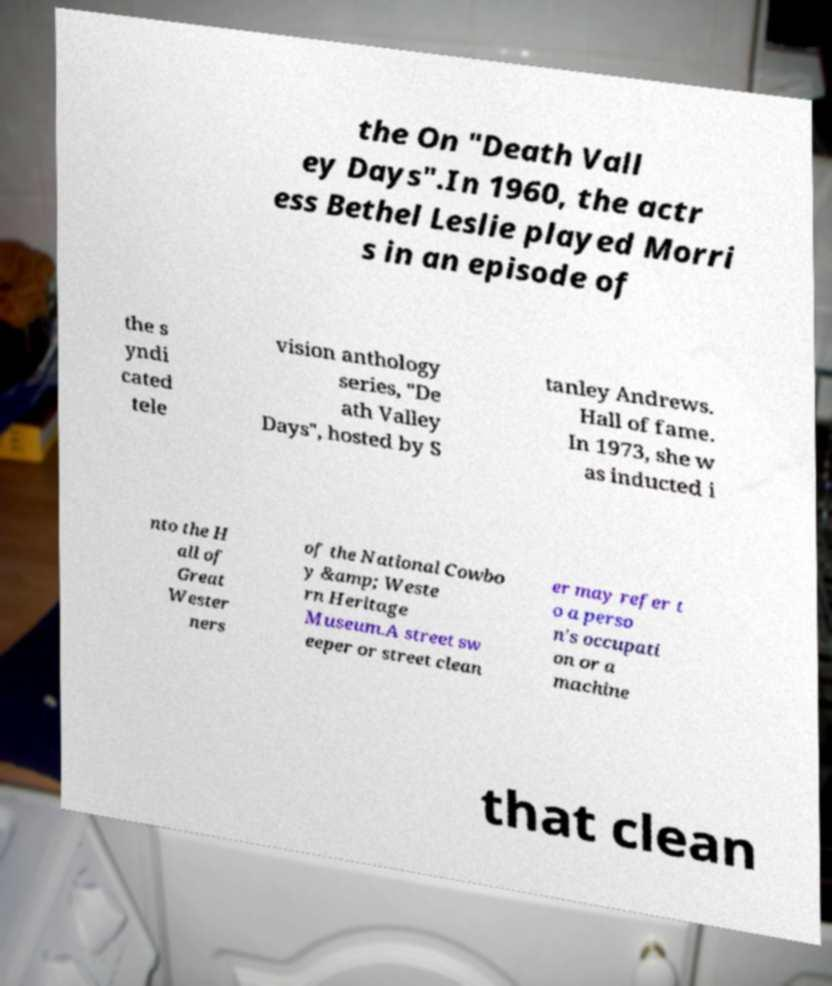There's text embedded in this image that I need extracted. Can you transcribe it verbatim? the On "Death Vall ey Days".In 1960, the actr ess Bethel Leslie played Morri s in an episode of the s yndi cated tele vision anthology series, "De ath Valley Days", hosted by S tanley Andrews. Hall of fame. In 1973, she w as inducted i nto the H all of Great Wester ners of the National Cowbo y &amp; Weste rn Heritage Museum.A street sw eeper or street clean er may refer t o a perso n's occupati on or a machine that clean 